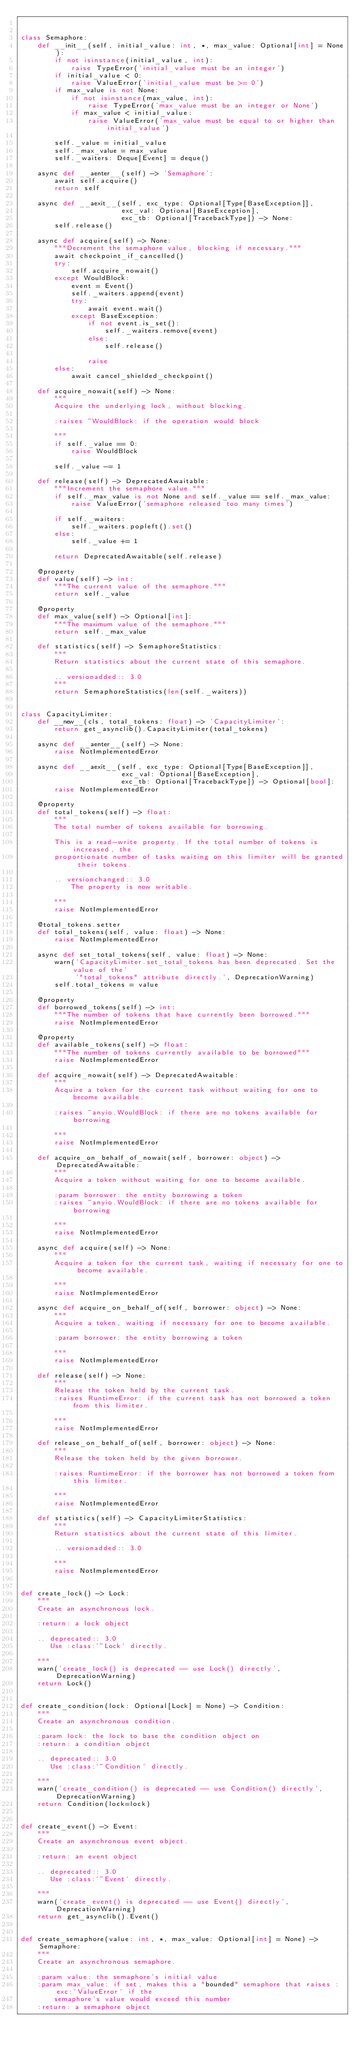<code> <loc_0><loc_0><loc_500><loc_500><_Python_>

class Semaphore:
    def __init__(self, initial_value: int, *, max_value: Optional[int] = None):
        if not isinstance(initial_value, int):
            raise TypeError('initial_value must be an integer')
        if initial_value < 0:
            raise ValueError('initial_value must be >= 0')
        if max_value is not None:
            if not isinstance(max_value, int):
                raise TypeError('max_value must be an integer or None')
            if max_value < initial_value:
                raise ValueError('max_value must be equal to or higher than initial_value')

        self._value = initial_value
        self._max_value = max_value
        self._waiters: Deque[Event] = deque()

    async def __aenter__(self) -> 'Semaphore':
        await self.acquire()
        return self

    async def __aexit__(self, exc_type: Optional[Type[BaseException]],
                        exc_val: Optional[BaseException],
                        exc_tb: Optional[TracebackType]) -> None:
        self.release()

    async def acquire(self) -> None:
        """Decrement the semaphore value, blocking if necessary."""
        await checkpoint_if_cancelled()
        try:
            self.acquire_nowait()
        except WouldBlock:
            event = Event()
            self._waiters.append(event)
            try:
                await event.wait()
            except BaseException:
                if not event.is_set():
                    self._waiters.remove(event)
                else:
                    self.release()

                raise
        else:
            await cancel_shielded_checkpoint()

    def acquire_nowait(self) -> None:
        """
        Acquire the underlying lock, without blocking.

        :raises ~WouldBlock: if the operation would block

        """
        if self._value == 0:
            raise WouldBlock

        self._value -= 1

    def release(self) -> DeprecatedAwaitable:
        """Increment the semaphore value."""
        if self._max_value is not None and self._value == self._max_value:
            raise ValueError('semaphore released too many times')

        if self._waiters:
            self._waiters.popleft().set()
        else:
            self._value += 1

        return DeprecatedAwaitable(self.release)

    @property
    def value(self) -> int:
        """The current value of the semaphore."""
        return self._value

    @property
    def max_value(self) -> Optional[int]:
        """The maximum value of the semaphore."""
        return self._max_value

    def statistics(self) -> SemaphoreStatistics:
        """
        Return statistics about the current state of this semaphore.

        .. versionadded:: 3.0
        """
        return SemaphoreStatistics(len(self._waiters))


class CapacityLimiter:
    def __new__(cls, total_tokens: float) -> 'CapacityLimiter':
        return get_asynclib().CapacityLimiter(total_tokens)

    async def __aenter__(self) -> None:
        raise NotImplementedError

    async def __aexit__(self, exc_type: Optional[Type[BaseException]],
                        exc_val: Optional[BaseException],
                        exc_tb: Optional[TracebackType]) -> Optional[bool]:
        raise NotImplementedError

    @property
    def total_tokens(self) -> float:
        """
        The total number of tokens available for borrowing.

        This is a read-write property. If the total number of tokens is increased, the
        proportionate number of tasks waiting on this limiter will be granted their tokens.

        .. versionchanged:: 3.0
            The property is now writable.

        """
        raise NotImplementedError

    @total_tokens.setter
    def total_tokens(self, value: float) -> None:
        raise NotImplementedError

    async def set_total_tokens(self, value: float) -> None:
        warn('CapacityLimiter.set_total_tokens has been deprecated. Set the value of the'
             '"total_tokens" attribute directly.', DeprecationWarning)
        self.total_tokens = value

    @property
    def borrowed_tokens(self) -> int:
        """The number of tokens that have currently been borrowed."""
        raise NotImplementedError

    @property
    def available_tokens(self) -> float:
        """The number of tokens currently available to be borrowed"""
        raise NotImplementedError

    def acquire_nowait(self) -> DeprecatedAwaitable:
        """
        Acquire a token for the current task without waiting for one to become available.

        :raises ~anyio.WouldBlock: if there are no tokens available for borrowing

        """
        raise NotImplementedError

    def acquire_on_behalf_of_nowait(self, borrower: object) -> DeprecatedAwaitable:
        """
        Acquire a token without waiting for one to become available.

        :param borrower: the entity borrowing a token
        :raises ~anyio.WouldBlock: if there are no tokens available for borrowing

        """
        raise NotImplementedError

    async def acquire(self) -> None:
        """
        Acquire a token for the current task, waiting if necessary for one to become available.

        """
        raise NotImplementedError

    async def acquire_on_behalf_of(self, borrower: object) -> None:
        """
        Acquire a token, waiting if necessary for one to become available.

        :param borrower: the entity borrowing a token

        """
        raise NotImplementedError

    def release(self) -> None:
        """
        Release the token held by the current task.
        :raises RuntimeError: if the current task has not borrowed a token from this limiter.

        """
        raise NotImplementedError

    def release_on_behalf_of(self, borrower: object) -> None:
        """
        Release the token held by the given borrower.

        :raises RuntimeError: if the borrower has not borrowed a token from this limiter.

        """
        raise NotImplementedError

    def statistics(self) -> CapacityLimiterStatistics:
        """
        Return statistics about the current state of this limiter.

        .. versionadded:: 3.0

        """
        raise NotImplementedError


def create_lock() -> Lock:
    """
    Create an asynchronous lock.

    :return: a lock object

    .. deprecated:: 3.0
       Use :class:`~Lock` directly.

    """
    warn('create_lock() is deprecated -- use Lock() directly', DeprecationWarning)
    return Lock()


def create_condition(lock: Optional[Lock] = None) -> Condition:
    """
    Create an asynchronous condition.

    :param lock: the lock to base the condition object on
    :return: a condition object

    .. deprecated:: 3.0
       Use :class:`~Condition` directly.

    """
    warn('create_condition() is deprecated -- use Condition() directly', DeprecationWarning)
    return Condition(lock=lock)


def create_event() -> Event:
    """
    Create an asynchronous event object.

    :return: an event object

    .. deprecated:: 3.0
       Use :class:`~Event` directly.

    """
    warn('create_event() is deprecated -- use Event() directly', DeprecationWarning)
    return get_asynclib().Event()


def create_semaphore(value: int, *, max_value: Optional[int] = None) -> Semaphore:
    """
    Create an asynchronous semaphore.

    :param value: the semaphore's initial value
    :param max_value: if set, makes this a "bounded" semaphore that raises :exc:`ValueError` if the
        semaphore's value would exceed this number
    :return: a semaphore object
</code> 